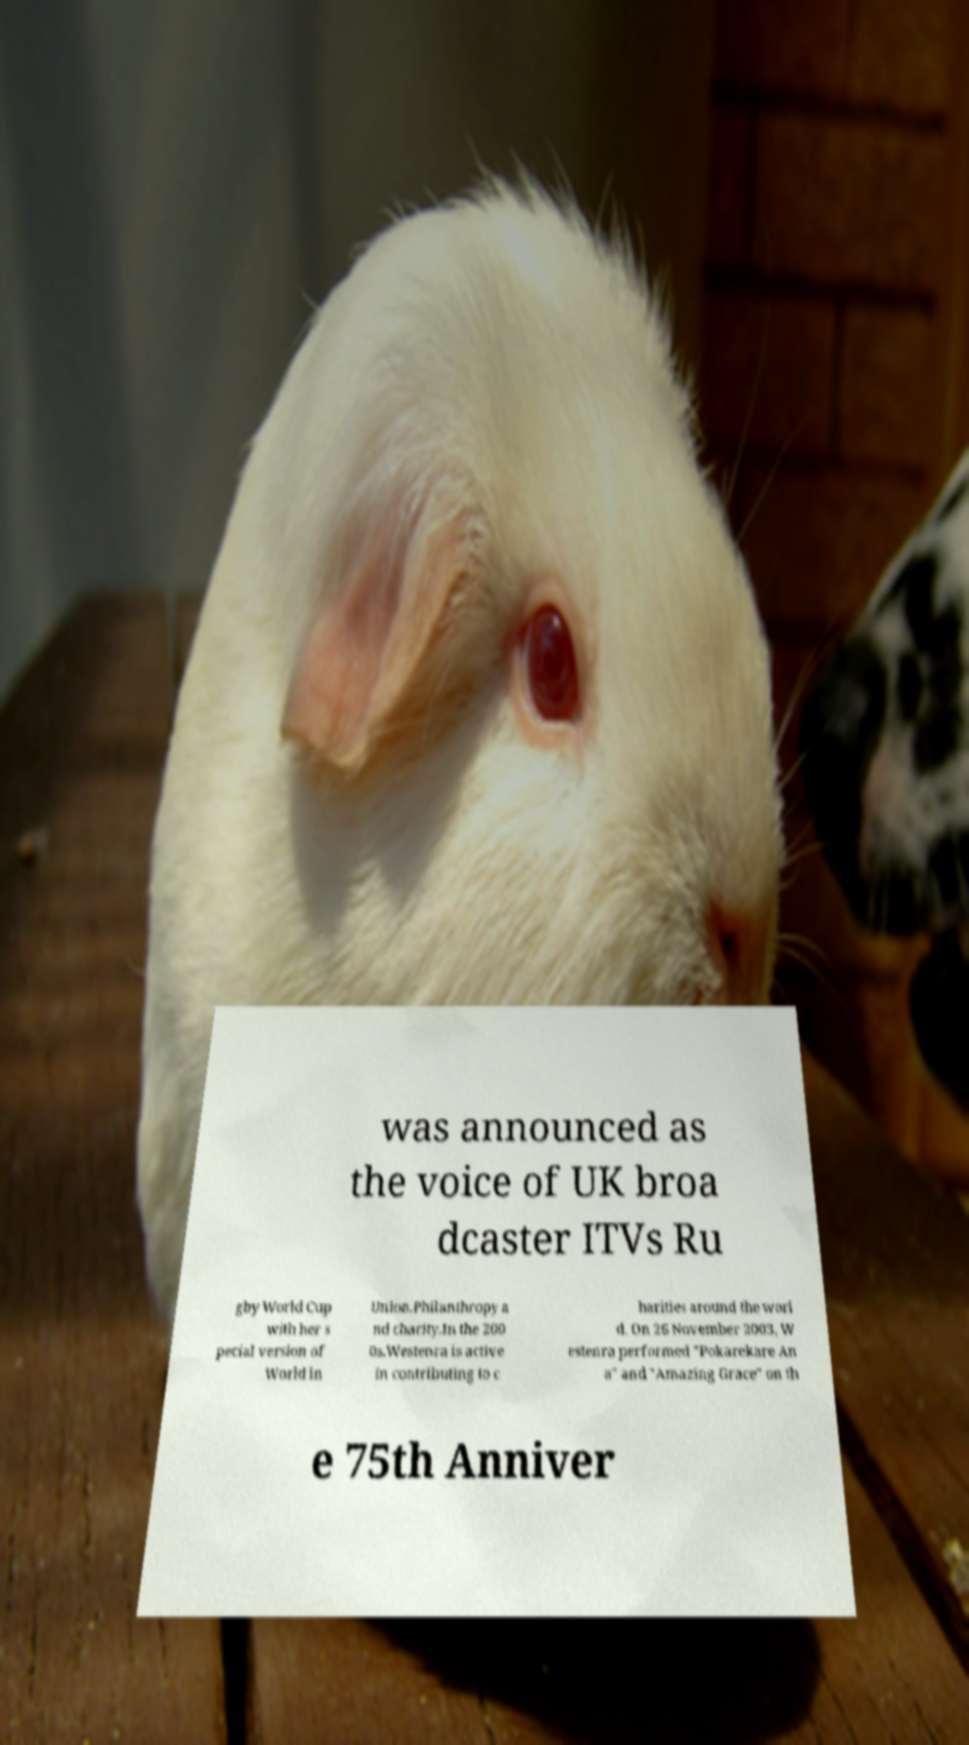Please identify and transcribe the text found in this image. was announced as the voice of UK broa dcaster ITVs Ru gby World Cup with her s pecial version of World in Union.Philanthropy a nd charity.In the 200 0s.Westenra is active in contributing to c harities around the worl d. On 26 November 2003, W estenra performed "Pokarekare An a" and "Amazing Grace" on th e 75th Anniver 